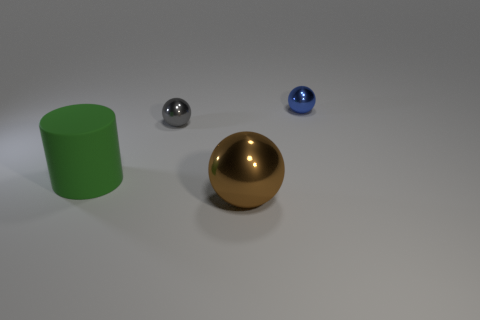What is the material of the big thing that is in front of the green matte cylinder? The large spherical object positioned in front of the green cylinder appears to be made of a reflective metal, possibly polished brass or gold, given its shiny, reflective golden hue. 